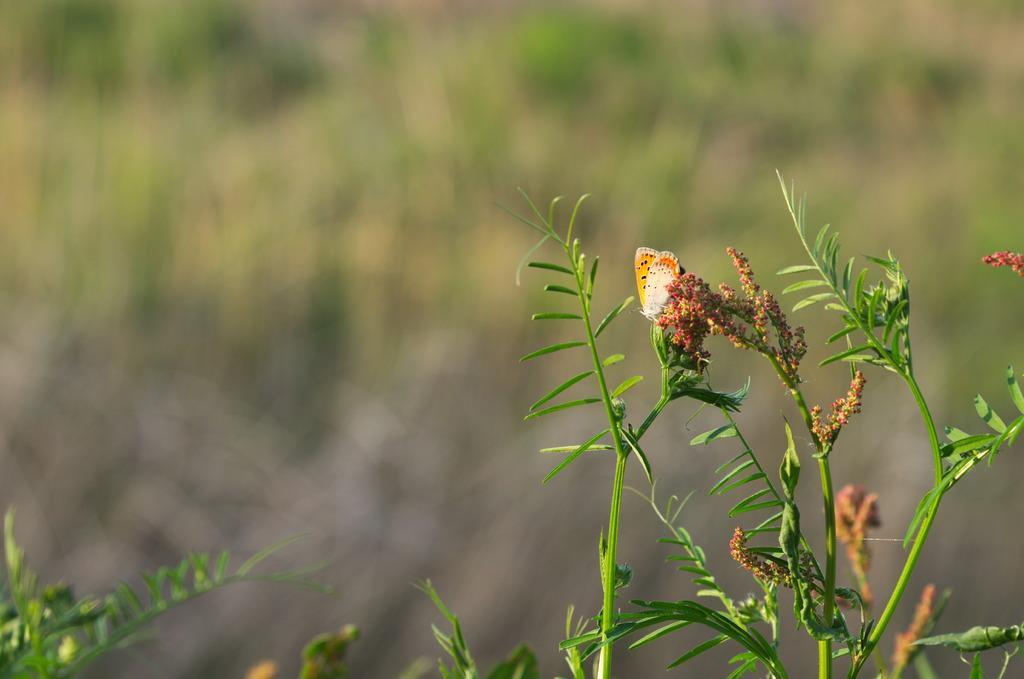In one or two sentences, can you explain what this image depicts? At the bottom of the picture, we see plants and a butterfly in white and orange color is on the plant. In the background, it is green in color and it is blurred in the background. 